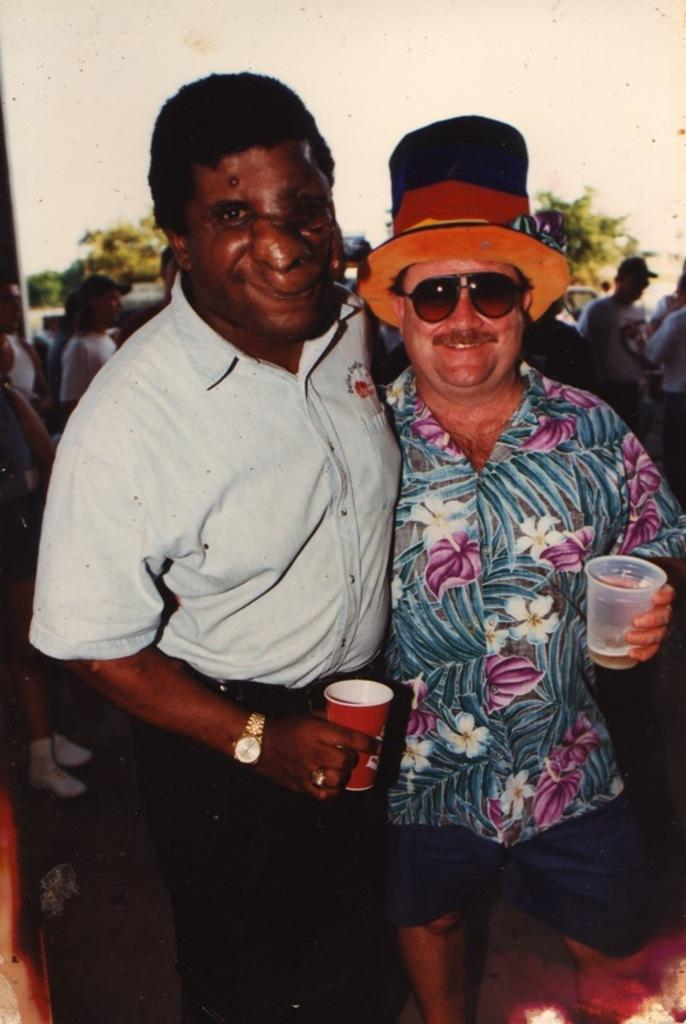How many people are in the image? There are two men in the image. What are the men doing in the image? The men are standing and smiling. What are the men holding in the image? The men are holding glasses. What can be seen in the background of the image? There are people, trees, and the sky visible in the background of the image. What type of knowledge can be gained from the owl in the image? There is no owl present in the image, so no knowledge can be gained from an owl. 